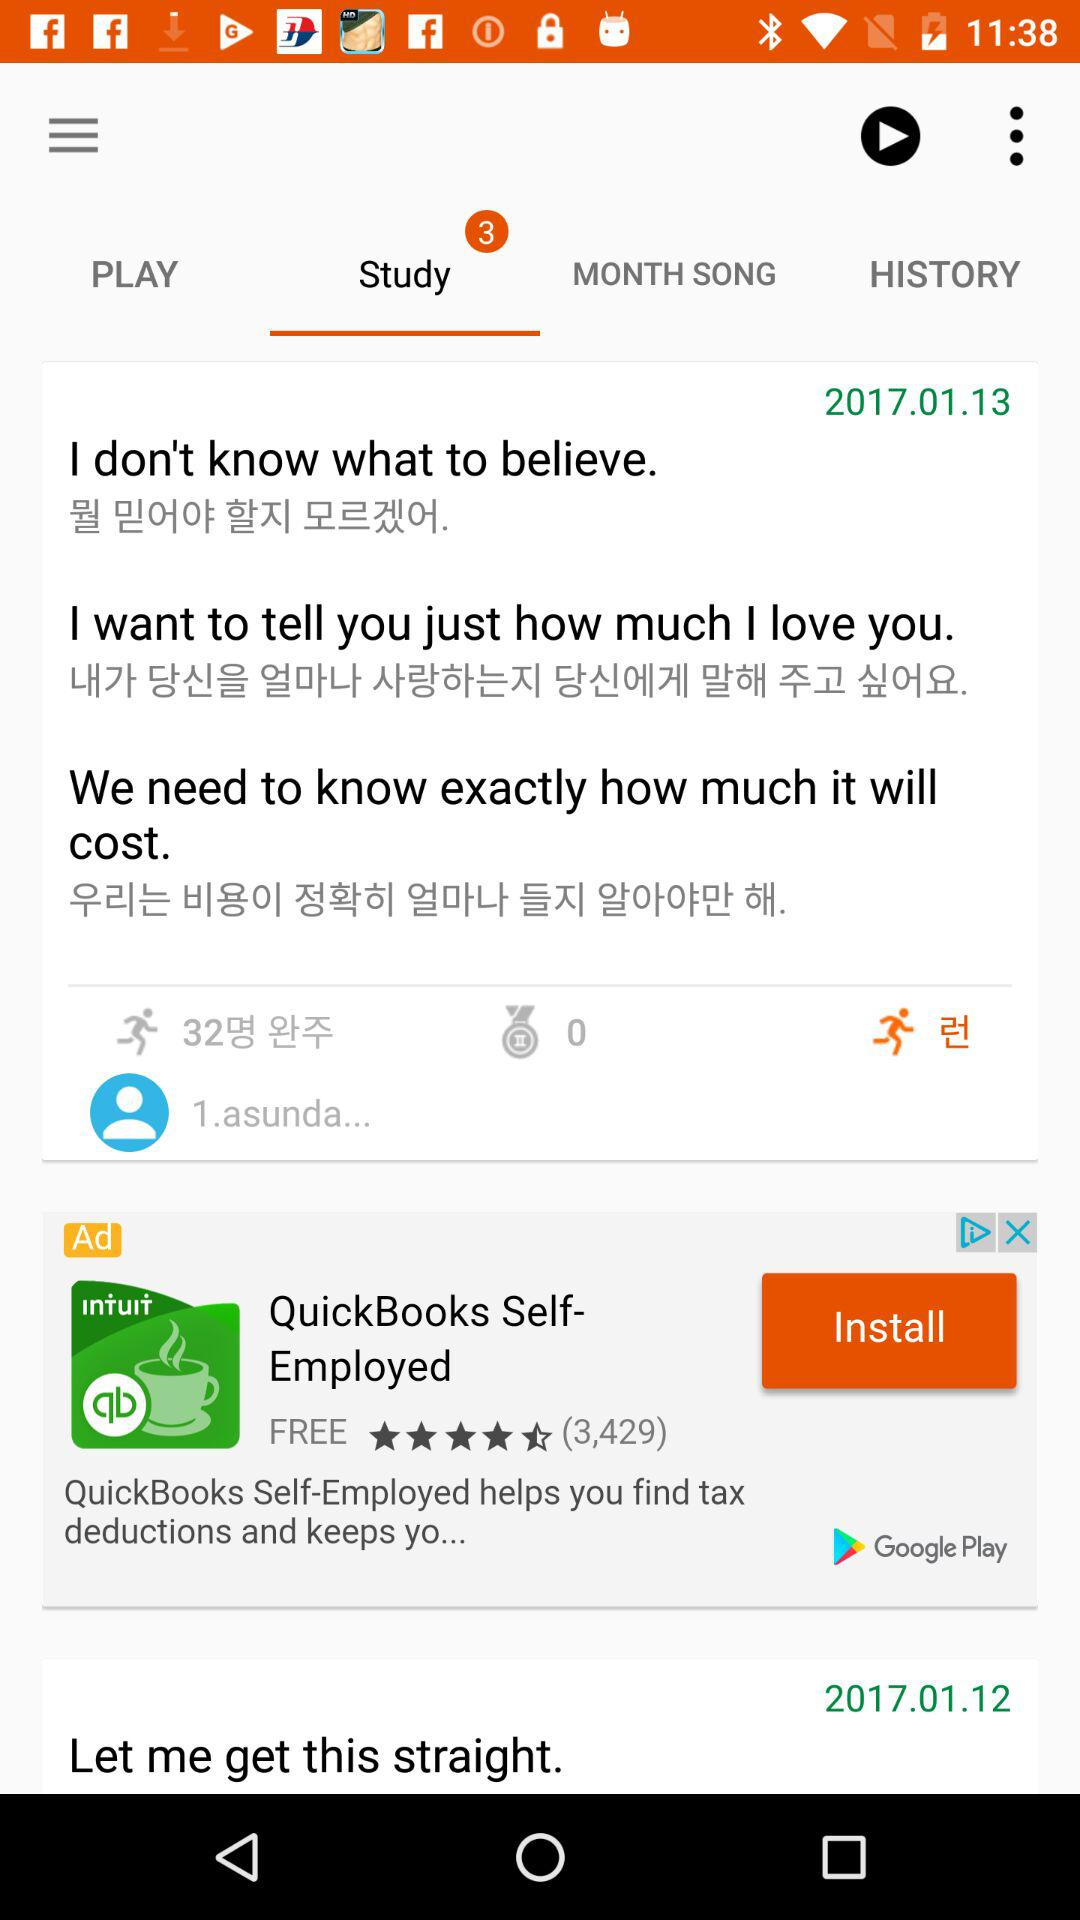How many notifications are there for "Study"? There are 3 notifications for "Study". 